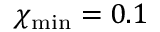Convert formula to latex. <formula><loc_0><loc_0><loc_500><loc_500>\chi _ { \min } = 0 . 1</formula> 